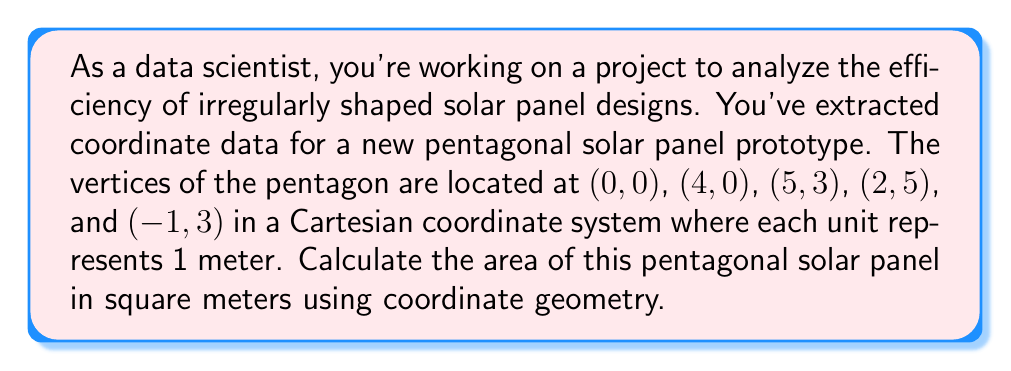Can you solve this math problem? To calculate the area of an irregular polygon using coordinate geometry, we can use the Shoelace formula (also known as the surveyor's formula). This method is particularly useful for a data scientist dealing with coordinate data.

The Shoelace formula for a polygon with n vertices $(x_1, y_1), (x_2, y_2), ..., (x_n, y_n)$ is:

$$ A = \frac{1}{2}|(x_1y_2 + x_2y_3 + ... + x_ny_1) - (y_1x_2 + y_2x_3 + ... + y_nx_1)| $$

Let's apply this formula to our pentagon:

1. List the coordinates in order:
   $(x_1, y_1) = (0, 0)$
   $(x_2, y_2) = (4, 0)$
   $(x_3, y_3) = (5, 3)$
   $(x_4, y_4) = (2, 5)$
   $(x_5, y_5) = (-1, 3)$

2. Calculate the first part of the formula:
   $x_1y_2 + x_2y_3 + x_3y_4 + x_4y_5 + x_5y_1$
   $= (0 \cdot 0) + (4 \cdot 3) + (5 \cdot 5) + (2 \cdot 3) + (-1 \cdot 0)$
   $= 0 + 12 + 25 + 6 + 0 = 43$

3. Calculate the second part of the formula:
   $y_1x_2 + y_2x_3 + y_3x_4 + y_4x_5 + y_5x_1$
   $= (0 \cdot 4) + (0 \cdot 5) + (3 \cdot 2) + (5 \cdot -1) + (3 \cdot 0)$
   $= 0 + 0 + 6 - 5 + 0 = 1$

4. Subtract the second part from the first part:
   $43 - 1 = 42$

5. Take the absolute value and divide by 2:
   $\frac{1}{2}|42| = 21$

Therefore, the area of the pentagonal solar panel is 21 square meters.
Answer: 21 square meters 